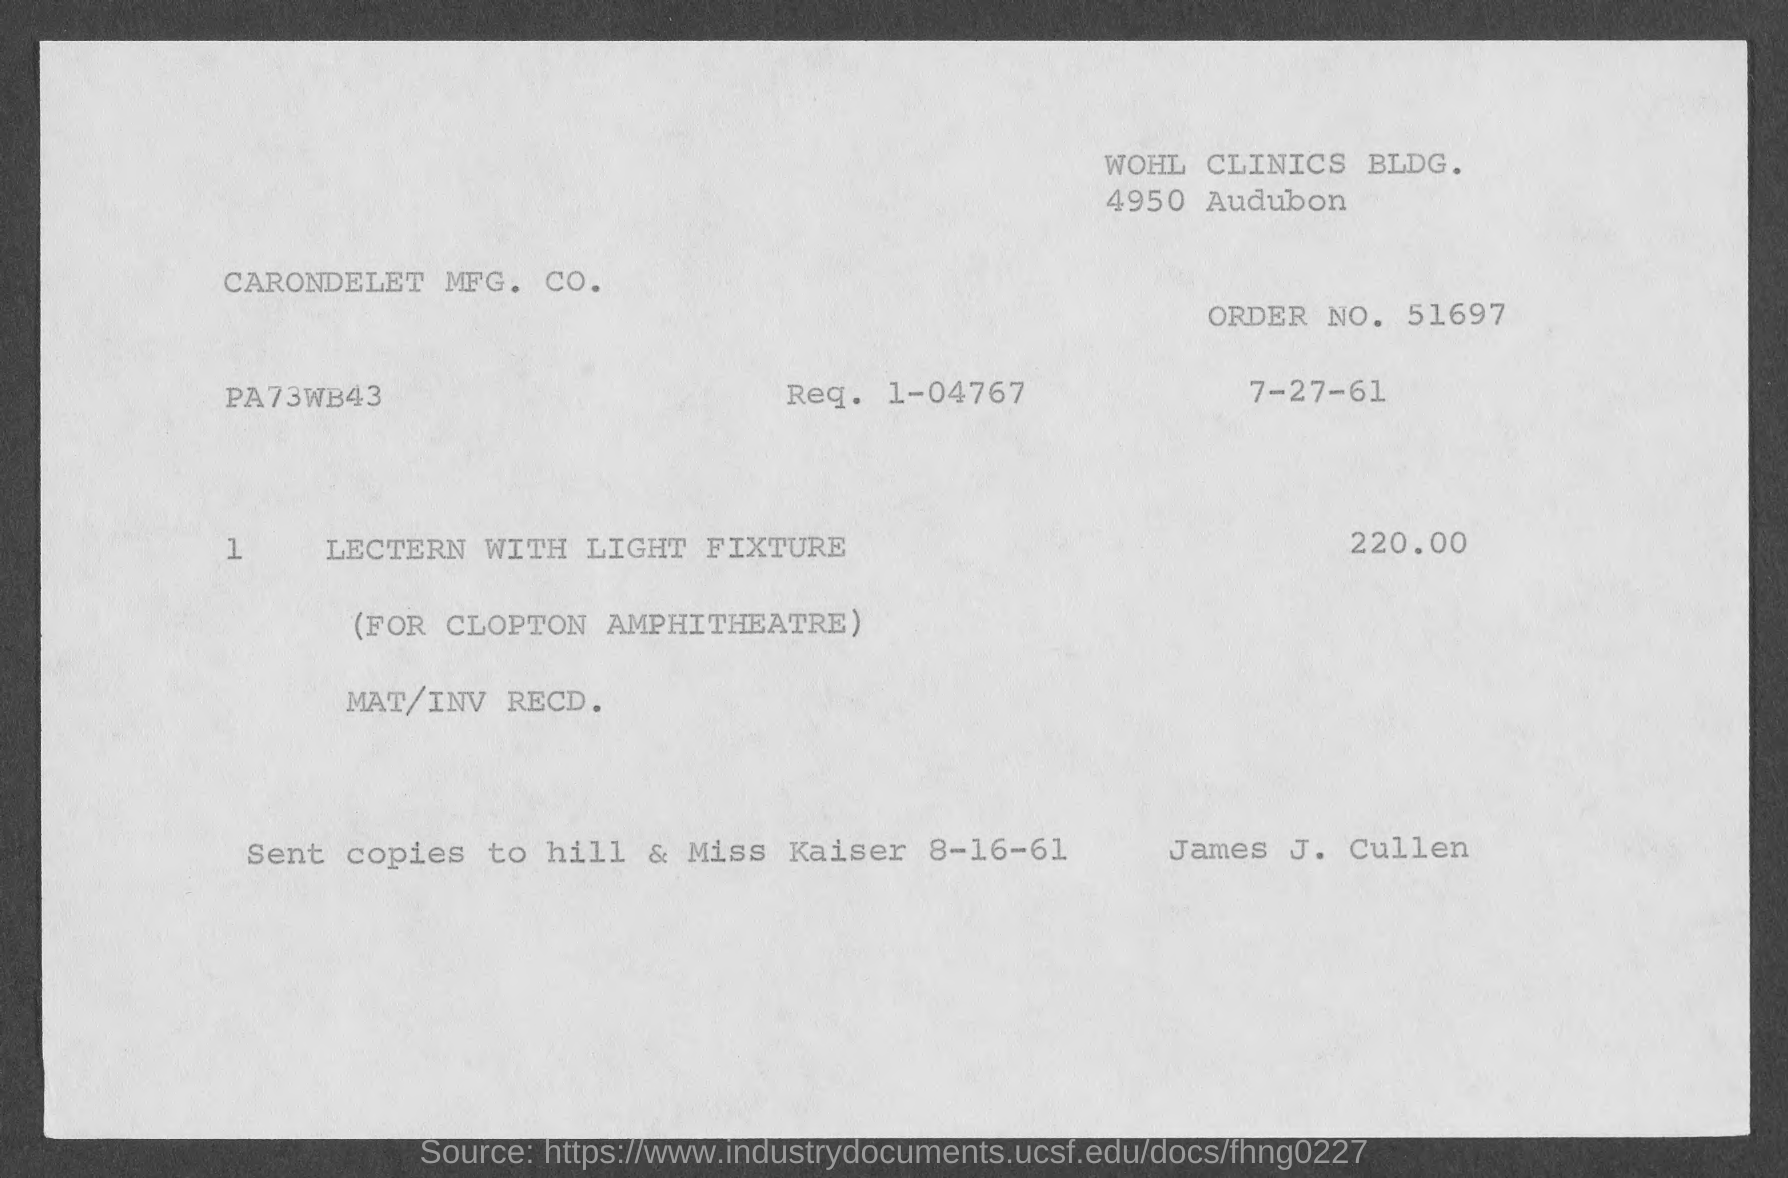What is the order no.?
Offer a very short reply. 51697. 